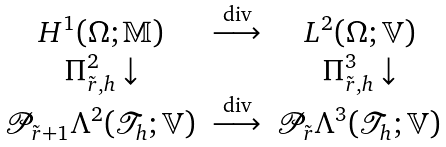Convert formula to latex. <formula><loc_0><loc_0><loc_500><loc_500>\begin{array} { c c c } H ^ { 1 } ( \Omega ; \mathbb { M } ) & \overset { \text {div} } { \longrightarrow } & L ^ { 2 } ( \Omega ; \mathbb { V } ) \\ \Pi _ { \tilde { r } , h } ^ { 2 } \downarrow & & \Pi _ { \tilde { r } , h } ^ { 3 } \downarrow \\ \mathcal { P } _ { \tilde { r } + 1 } \Lambda ^ { 2 } ( \mathcal { T } _ { h } ; \mathbb { V } ) & \overset { \text {div} } { \longrightarrow } & \mathcal { P } _ { \tilde { r } } \Lambda ^ { 3 } ( \mathcal { T } _ { h } ; \mathbb { V } ) \end{array}</formula> 